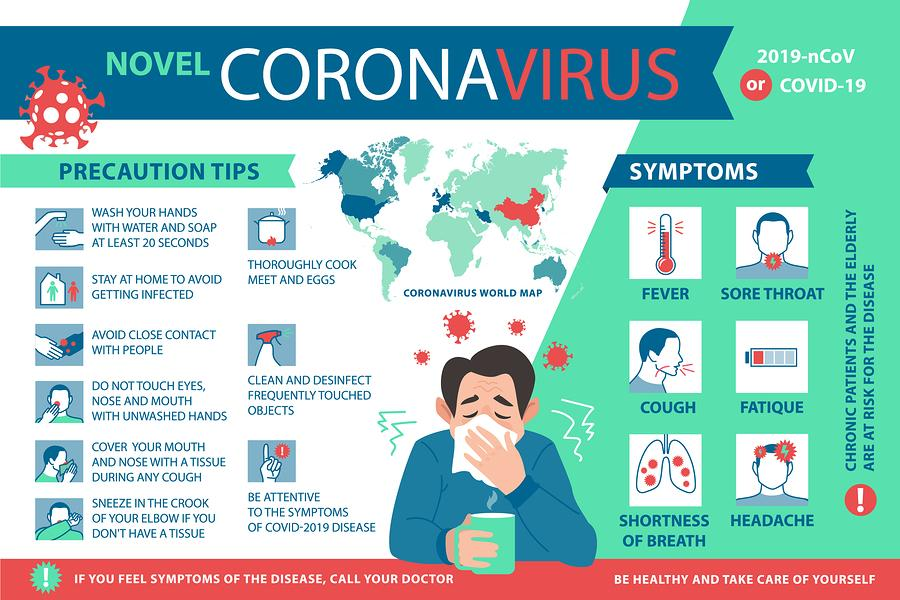Specify some key components in this picture. The first three symptoms depicted in the image are fever, sore throat, and cough. Fatigue is the second symptom that is shown in the second row. The first symptom displayed in the third row is shortness of breath. It is observed that 6 symptoms are depicted in the image. The second symptom shown in the third row is a headache. 